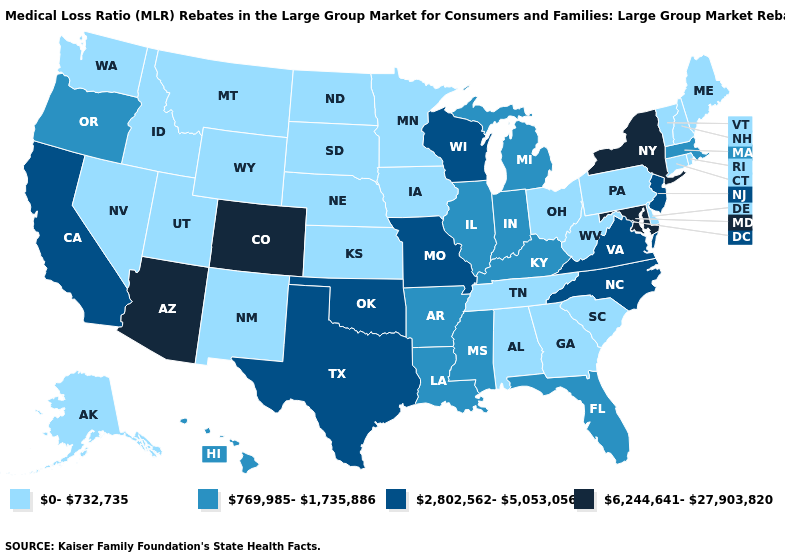Name the states that have a value in the range 769,985-1,735,886?
Be succinct. Arkansas, Florida, Hawaii, Illinois, Indiana, Kentucky, Louisiana, Massachusetts, Michigan, Mississippi, Oregon. Name the states that have a value in the range 6,244,641-27,903,820?
Give a very brief answer. Arizona, Colorado, Maryland, New York. Does West Virginia have the highest value in the USA?
Quick response, please. No. What is the value of Pennsylvania?
Quick response, please. 0-732,735. Name the states that have a value in the range 2,802,562-5,053,056?
Answer briefly. California, Missouri, New Jersey, North Carolina, Oklahoma, Texas, Virginia, Wisconsin. What is the value of Arkansas?
Be succinct. 769,985-1,735,886. What is the value of Missouri?
Write a very short answer. 2,802,562-5,053,056. Does Oregon have the lowest value in the West?
Keep it brief. No. Which states hav the highest value in the Northeast?
Quick response, please. New York. What is the value of Montana?
Answer briefly. 0-732,735. How many symbols are there in the legend?
Short answer required. 4. What is the value of Maryland?
Quick response, please. 6,244,641-27,903,820. Does the first symbol in the legend represent the smallest category?
Be succinct. Yes. What is the lowest value in the USA?
Keep it brief. 0-732,735. 